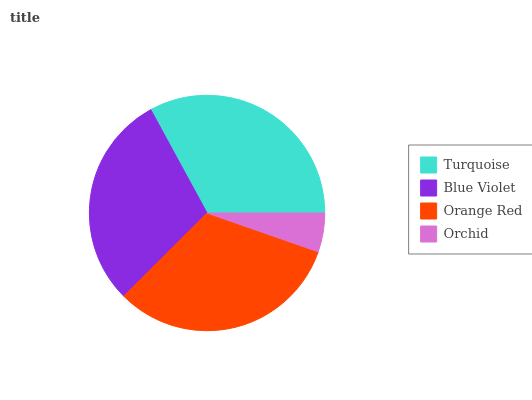Is Orchid the minimum?
Answer yes or no. Yes. Is Turquoise the maximum?
Answer yes or no. Yes. Is Blue Violet the minimum?
Answer yes or no. No. Is Blue Violet the maximum?
Answer yes or no. No. Is Turquoise greater than Blue Violet?
Answer yes or no. Yes. Is Blue Violet less than Turquoise?
Answer yes or no. Yes. Is Blue Violet greater than Turquoise?
Answer yes or no. No. Is Turquoise less than Blue Violet?
Answer yes or no. No. Is Orange Red the high median?
Answer yes or no. Yes. Is Blue Violet the low median?
Answer yes or no. Yes. Is Orchid the high median?
Answer yes or no. No. Is Turquoise the low median?
Answer yes or no. No. 